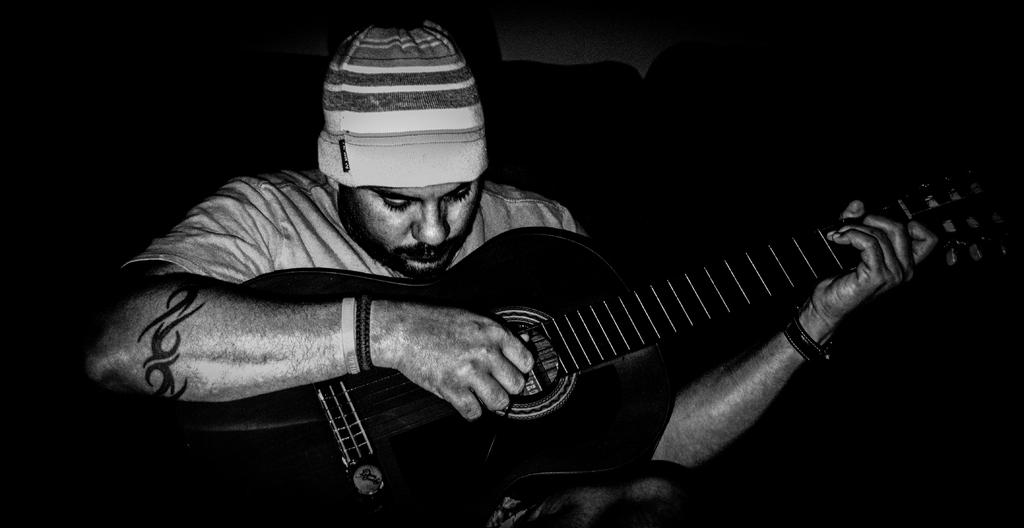What is the main subject of the image? The main subject of the image is a man. What is the man doing in the image? The man is playing a guitar in the image. What type of brush is the man using to play the guitar in the image? There is no brush present in the image; the man is playing the guitar with his hands. Can you see any socks on the man's feet in the image? The image does not show the man's feet, so it is impossible to determine if he is wearing socks. 